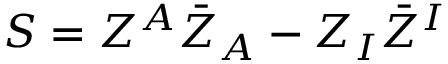Convert formula to latex. <formula><loc_0><loc_0><loc_500><loc_500>S = Z ^ { A } \bar { Z } _ { A } - Z _ { I } \bar { Z } ^ { I }</formula> 